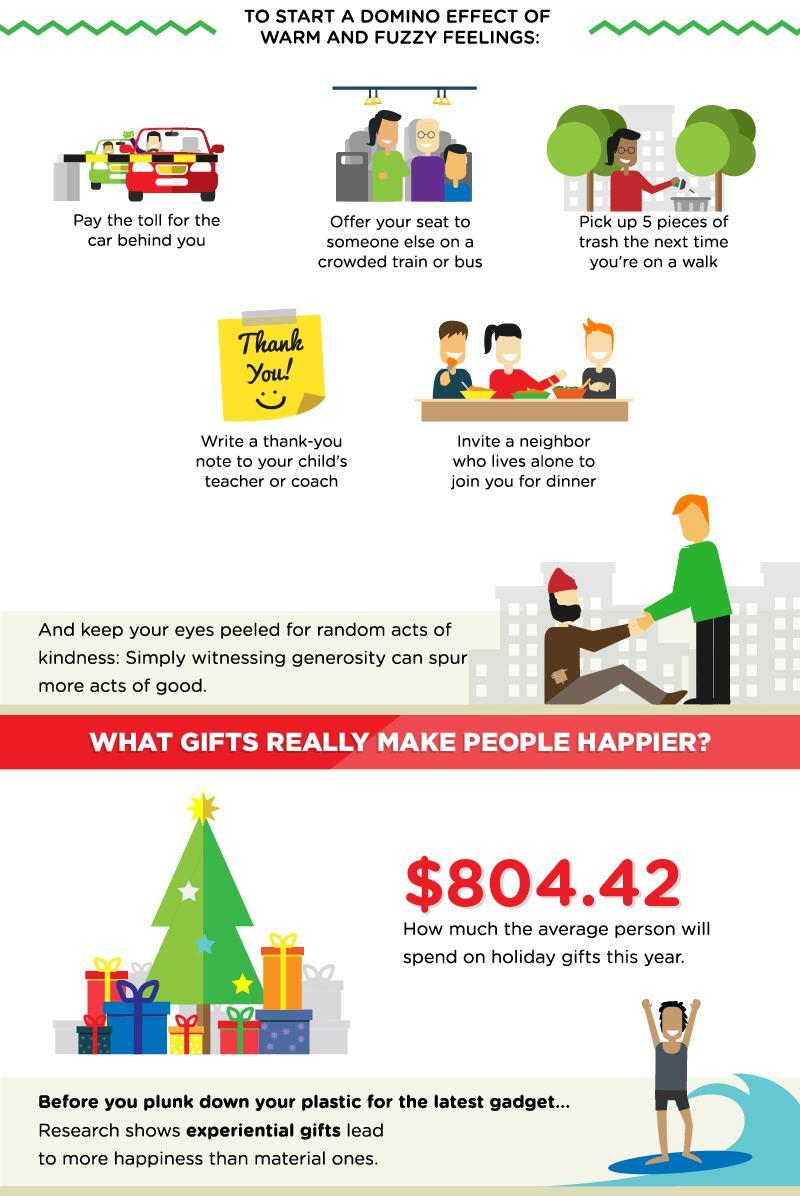Which is the fourth way to start a domino effect of warm and fuzzy feelings?
Answer the question with a short phrase. Write a thank-you note to your child's teacher or coach 